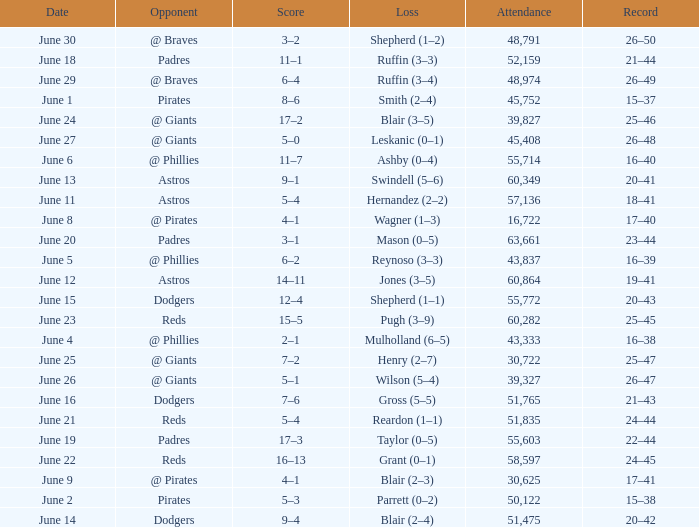Could you parse the entire table as a dict? {'header': ['Date', 'Opponent', 'Score', 'Loss', 'Attendance', 'Record'], 'rows': [['June 30', '@ Braves', '3–2', 'Shepherd (1–2)', '48,791', '26–50'], ['June 18', 'Padres', '11–1', 'Ruffin (3–3)', '52,159', '21–44'], ['June 29', '@ Braves', '6–4', 'Ruffin (3–4)', '48,974', '26–49'], ['June 1', 'Pirates', '8–6', 'Smith (2–4)', '45,752', '15–37'], ['June 24', '@ Giants', '17–2', 'Blair (3–5)', '39,827', '25–46'], ['June 27', '@ Giants', '5–0', 'Leskanic (0–1)', '45,408', '26–48'], ['June 6', '@ Phillies', '11–7', 'Ashby (0–4)', '55,714', '16–40'], ['June 13', 'Astros', '9–1', 'Swindell (5–6)', '60,349', '20–41'], ['June 11', 'Astros', '5–4', 'Hernandez (2–2)', '57,136', '18–41'], ['June 8', '@ Pirates', '4–1', 'Wagner (1–3)', '16,722', '17–40'], ['June 20', 'Padres', '3–1', 'Mason (0–5)', '63,661', '23–44'], ['June 5', '@ Phillies', '6–2', 'Reynoso (3–3)', '43,837', '16–39'], ['June 12', 'Astros', '14–11', 'Jones (3–5)', '60,864', '19–41'], ['June 15', 'Dodgers', '12–4', 'Shepherd (1–1)', '55,772', '20–43'], ['June 23', 'Reds', '15–5', 'Pugh (3–9)', '60,282', '25–45'], ['June 4', '@ Phillies', '2–1', 'Mulholland (6–5)', '43,333', '16–38'], ['June 25', '@ Giants', '7–2', 'Henry (2–7)', '30,722', '25–47'], ['June 26', '@ Giants', '5–1', 'Wilson (5–4)', '39,327', '26–47'], ['June 16', 'Dodgers', '7–6', 'Gross (5–5)', '51,765', '21–43'], ['June 21', 'Reds', '5–4', 'Reardon (1–1)', '51,835', '24–44'], ['June 19', 'Padres', '17–3', 'Taylor (0–5)', '55,603', '22–44'], ['June 22', 'Reds', '16–13', 'Grant (0–1)', '58,597', '24–45'], ['June 9', '@ Pirates', '4–1', 'Blair (2–3)', '30,625', '17–41'], ['June 2', 'Pirates', '5–3', 'Parrett (0–2)', '50,122', '15–38'], ['June 14', 'Dodgers', '9–4', 'Blair (2–4)', '51,475', '20–42']]} What was the score on June 12? 14–11. 